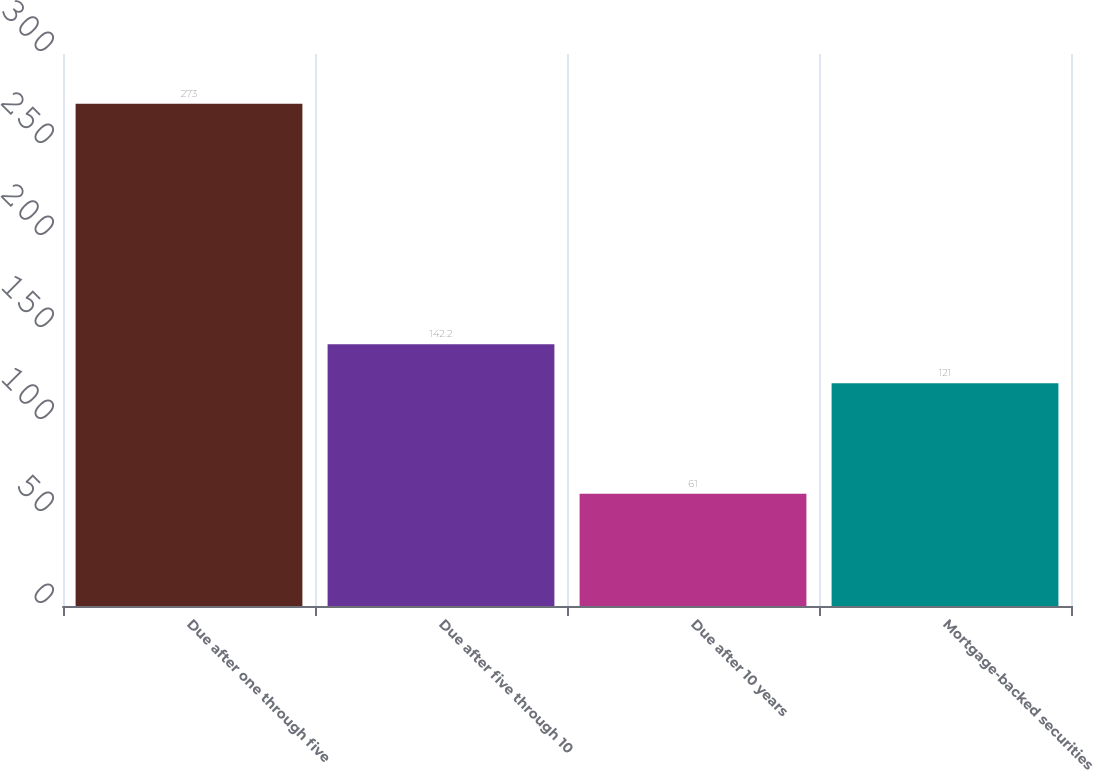Convert chart to OTSL. <chart><loc_0><loc_0><loc_500><loc_500><bar_chart><fcel>Due after one through five<fcel>Due after five through 10<fcel>Due after 10 years<fcel>Mortgage-backed securities<nl><fcel>273<fcel>142.2<fcel>61<fcel>121<nl></chart> 